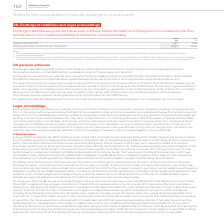From Vodafone Group Plc's financial document, What does contingent liabilities consist of? The document shows two values: Performance bonds and Other guarantees and contingent liabilities. From the document: "2019 2018 €m €m Performance bonds 1 337 993 Other guarantees and contingent liabilities 2 2,943 4,036 2019 2018 €m €m Performance bonds 1 337 993 Othe..." Also, What are contingent liabilities? potential future cash outflows, where the likelihood of payment is considered more than remote, but is not considered probable or cannot be measured reliably. The document states: "Contingent liabilities are potential future cash outflows, where the likelihood of payment is considered more than remote, but is not considered proba..." Also, How much are the 2019 performance bonds? According to the financial document, 337 (in millions). The relevant text states: "2019 2018 €m €m Performance bonds 1 337 993 Other guarantees and contingent liabilities 2 2,943 4,036..." Also, can you calculate: What is the 2019 average performance bonds? To answer this question, I need to perform calculations using the financial data. The calculation is: (337+993)/2, which equals 665 (in millions). This is based on the information: "2019 2018 €m €m Performance bonds 1 337 993 Other guarantees and contingent liabilities 2 2,943 4,036 2019 2018 €m €m Performance bonds 1 337 993 Other guarantees and contingent liabilities 2 2,943 4,..." The key data points involved are: 337, 993. Also, can you calculate: What is the 2019 average other guarantees and contingent liabilities? To answer this question, I need to perform calculations using the financial data. The calculation is: (2,943+4,036)/2, which equals 3489.5 (in millions). This is based on the information: "her guarantees and contingent liabilities 2 2,943 4,036 993 Other guarantees and contingent liabilities 2 2,943 4,036..." The key data points involved are: 2,943, 4,036. Also, can you calculate: What is the difference between 2019 average performance bonds and 2019 average other guarantees and contingent liabilities? To answer this question, I need to perform calculations using the financial data. The calculation is: [(2,943+4,036)/2] - [(337+993)/2], which equals 2824.5 (in millions). This is based on the information: "her guarantees and contingent liabilities 2 2,943 4,036 2019 2018 €m €m Performance bonds 1 337 993 Other guarantees and contingent liabilities 2 2,943 4,036 993 Other guarantees and contingent liabil..." The key data points involved are: 2,943, 337, 4,036. 